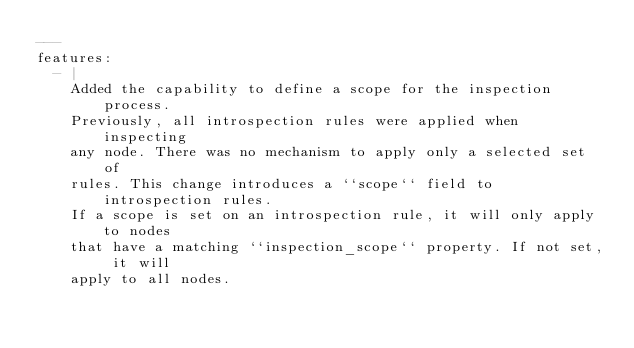Convert code to text. <code><loc_0><loc_0><loc_500><loc_500><_YAML_>---
features:
  - |
    Added the capability to define a scope for the inspection process.
    Previously, all introspection rules were applied when inspecting
    any node. There was no mechanism to apply only a selected set of
    rules. This change introduces a ``scope`` field to introspection rules.
    If a scope is set on an introspection rule, it will only apply to nodes
    that have a matching ``inspection_scope`` property. If not set, it will
    apply to all nodes.</code> 